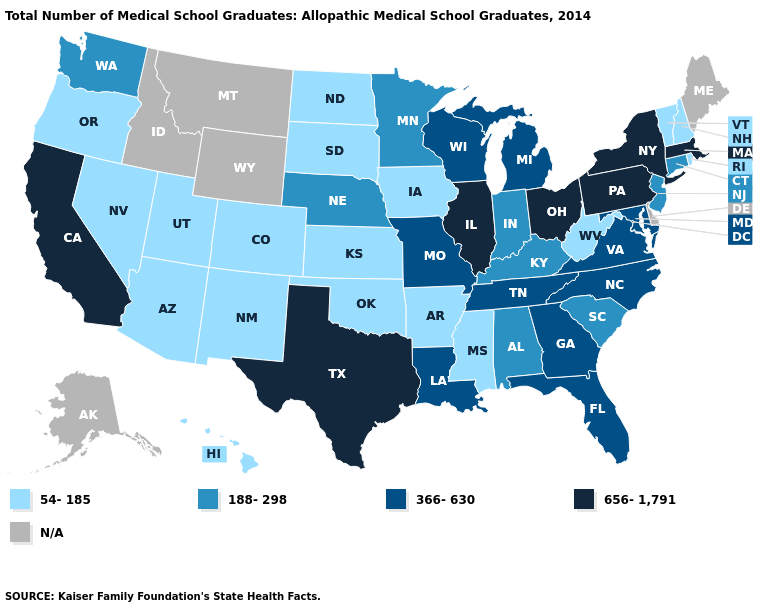What is the lowest value in the MidWest?
Write a very short answer. 54-185. Name the states that have a value in the range 54-185?
Be succinct. Arizona, Arkansas, Colorado, Hawaii, Iowa, Kansas, Mississippi, Nevada, New Hampshire, New Mexico, North Dakota, Oklahoma, Oregon, Rhode Island, South Dakota, Utah, Vermont, West Virginia. Which states hav the highest value in the South?
Write a very short answer. Texas. Name the states that have a value in the range 188-298?
Concise answer only. Alabama, Connecticut, Indiana, Kentucky, Minnesota, Nebraska, New Jersey, South Carolina, Washington. Among the states that border Nevada , which have the lowest value?
Write a very short answer. Arizona, Oregon, Utah. Among the states that border New York , which have the highest value?
Keep it brief. Massachusetts, Pennsylvania. What is the value of Utah?
Answer briefly. 54-185. What is the lowest value in states that border Idaho?
Be succinct. 54-185. What is the value of Hawaii?
Short answer required. 54-185. Name the states that have a value in the range N/A?
Answer briefly. Alaska, Delaware, Idaho, Maine, Montana, Wyoming. Among the states that border Illinois , which have the lowest value?
Quick response, please. Iowa. What is the lowest value in states that border Oregon?
Answer briefly. 54-185. Which states have the lowest value in the West?
Give a very brief answer. Arizona, Colorado, Hawaii, Nevada, New Mexico, Oregon, Utah. Name the states that have a value in the range 366-630?
Answer briefly. Florida, Georgia, Louisiana, Maryland, Michigan, Missouri, North Carolina, Tennessee, Virginia, Wisconsin. What is the highest value in the USA?
Answer briefly. 656-1,791. 